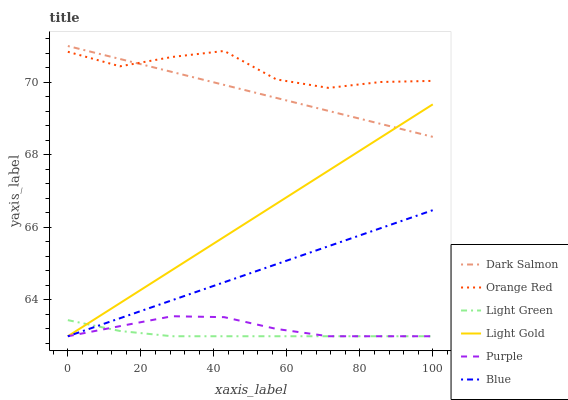Does Light Green have the minimum area under the curve?
Answer yes or no. Yes. Does Orange Red have the maximum area under the curve?
Answer yes or no. Yes. Does Purple have the minimum area under the curve?
Answer yes or no. No. Does Purple have the maximum area under the curve?
Answer yes or no. No. Is Light Gold the smoothest?
Answer yes or no. Yes. Is Orange Red the roughest?
Answer yes or no. Yes. Is Purple the smoothest?
Answer yes or no. No. Is Purple the roughest?
Answer yes or no. No. Does Blue have the lowest value?
Answer yes or no. Yes. Does Dark Salmon have the lowest value?
Answer yes or no. No. Does Dark Salmon have the highest value?
Answer yes or no. Yes. Does Purple have the highest value?
Answer yes or no. No. Is Blue less than Orange Red?
Answer yes or no. Yes. Is Dark Salmon greater than Blue?
Answer yes or no. Yes. Does Light Green intersect Light Gold?
Answer yes or no. Yes. Is Light Green less than Light Gold?
Answer yes or no. No. Is Light Green greater than Light Gold?
Answer yes or no. No. Does Blue intersect Orange Red?
Answer yes or no. No. 